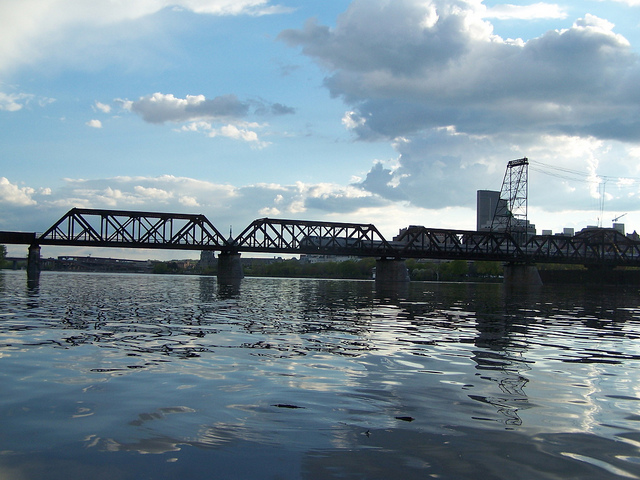<image>Which of the buildings appears tallest? It is ambiguous which building appears tallest. It could be the one behind the bridge, on the right side or in the middle. What kind of boat is in the center of the picture? There is no boat in the center of the picture. Which of the buildings appears tallest? It is ambiguous which of the buildings appears tallest. The options given are not clear. What kind of boat is in the center of the picture? There is no boat in the center of the picture. 